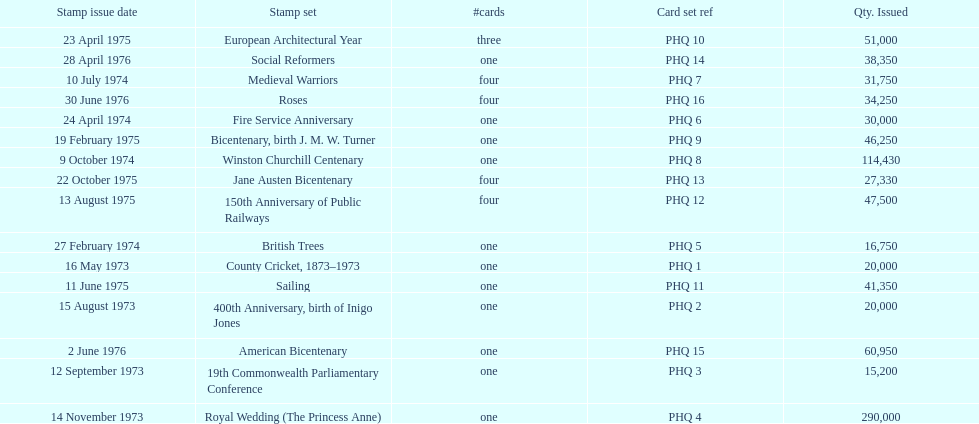Which was the only stamp set to have more than 200,000 issued? Royal Wedding (The Princess Anne). 